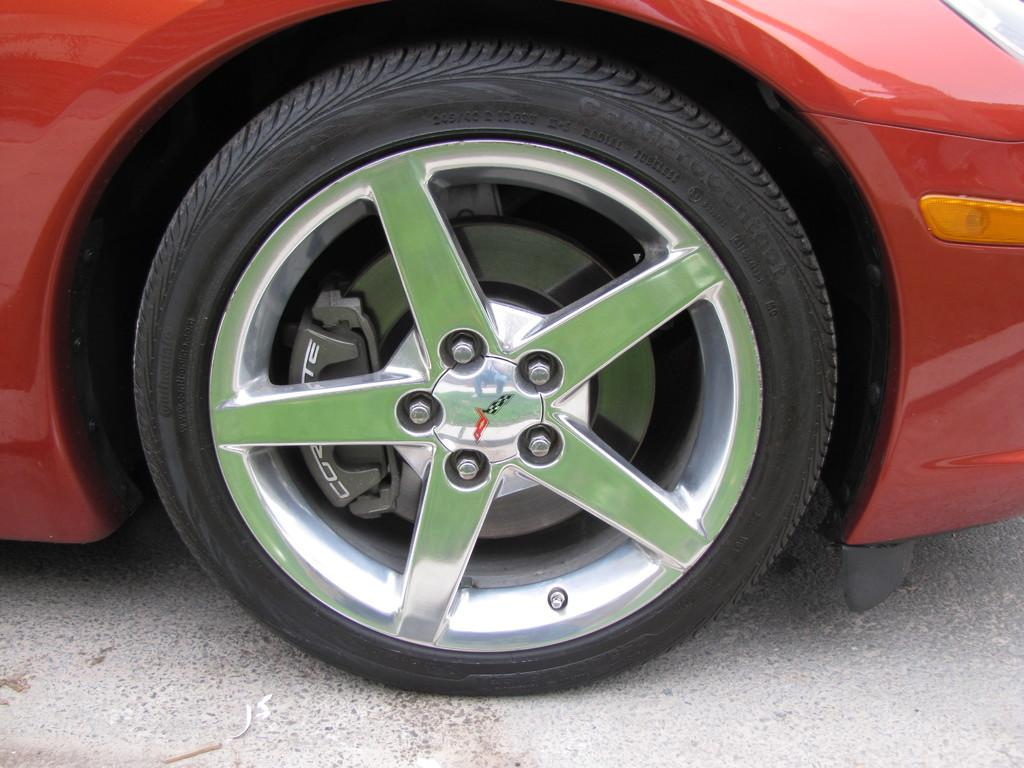What is the main subject of the image? The main subject of the image is a wheel of a vehicle. Where is the wheel located? The wheel is on the road. Can you see any worms crawling on the wheel in the image? There are no worms present in the image; it only features a wheel on the road. What type of bead is used to decorate the wheel in the image? There are no beads present on the wheel in the image. 